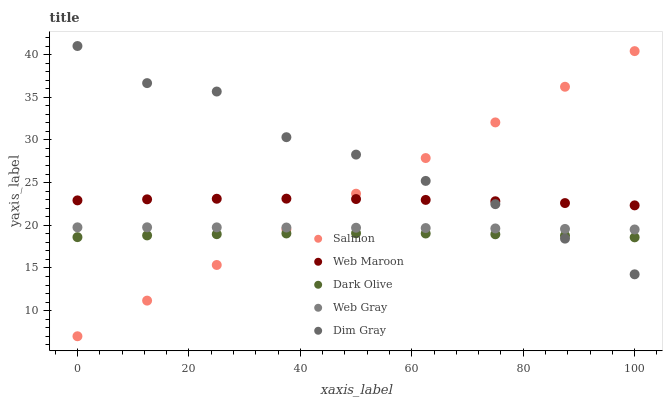Does Dark Olive have the minimum area under the curve?
Answer yes or no. Yes. Does Dim Gray have the maximum area under the curve?
Answer yes or no. Yes. Does Web Maroon have the minimum area under the curve?
Answer yes or no. No. Does Web Maroon have the maximum area under the curve?
Answer yes or no. No. Is Salmon the smoothest?
Answer yes or no. Yes. Is Dim Gray the roughest?
Answer yes or no. Yes. Is Web Maroon the smoothest?
Answer yes or no. No. Is Web Maroon the roughest?
Answer yes or no. No. Does Salmon have the lowest value?
Answer yes or no. Yes. Does Dim Gray have the lowest value?
Answer yes or no. No. Does Dim Gray have the highest value?
Answer yes or no. Yes. Does Web Maroon have the highest value?
Answer yes or no. No. Is Dark Olive less than Web Gray?
Answer yes or no. Yes. Is Web Gray greater than Dark Olive?
Answer yes or no. Yes. Does Web Gray intersect Dim Gray?
Answer yes or no. Yes. Is Web Gray less than Dim Gray?
Answer yes or no. No. Is Web Gray greater than Dim Gray?
Answer yes or no. No. Does Dark Olive intersect Web Gray?
Answer yes or no. No. 